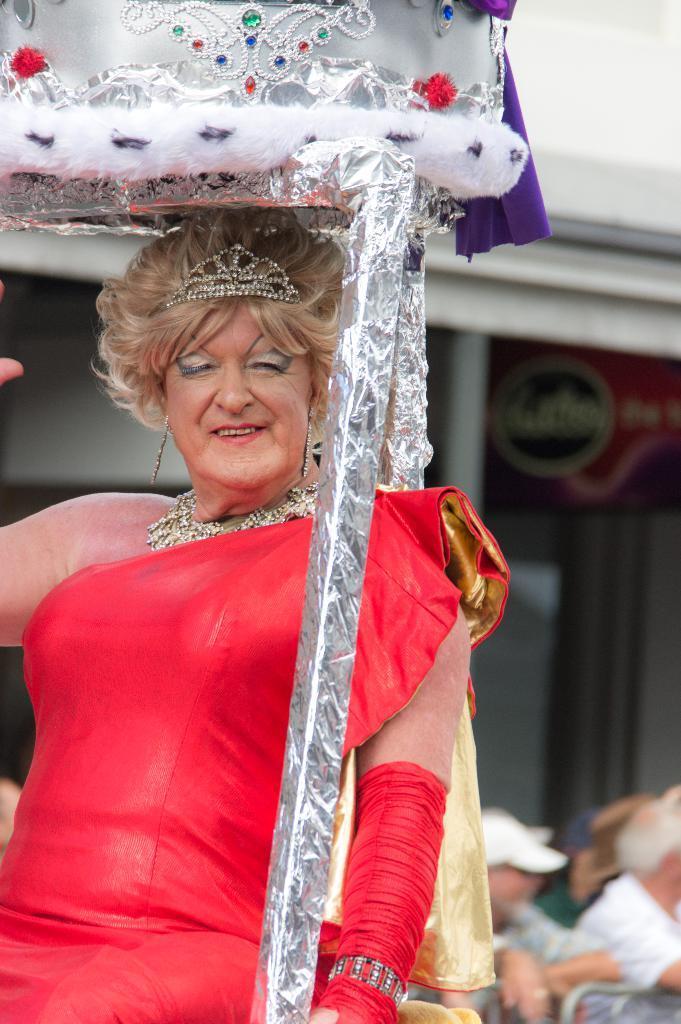Can you describe this image briefly? In this image I can see the person wearing the red color dress and the person is under the silver color decorative object. In the background I can see the group of people and the building with board. I can see there is a blurred background. 